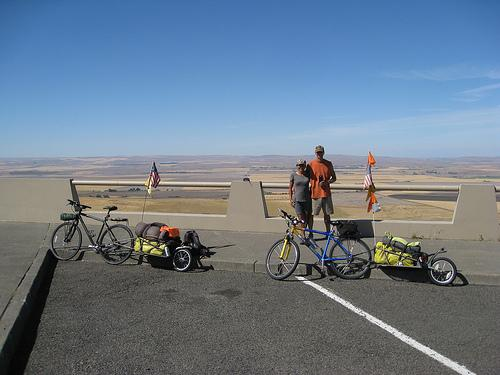What is the state of the sky in the image? The sky in the image is blue with white clouds. What are the two people in the image wearing? The male is wearing an orange shirt, and the female is wearing a gray shirt. Are there any flags in the image? If yes, describe the flags. Yes, there are flags in the image, including an American flag and a set of colored flags. Provide a brief description of the scene in the image. The image shows a row of bicycles with back seats parked in a gray parking lot, with owners nearby, under a blue sky with white clouds. Identify the primary object in the image and its color. The primary object in the image is a black bicycle with a back seat. What type of bikes are the black and blue bicycles? The black and blue bicycles are mountain bikes with back seats. What elements of the image reveal the season or weather conditions at the time the photo was taken? The blue sky with white clouds, owners of bicycles wearing shirts, and the clear atmosphere indicate that it might be a warm and sunny day during spring or summer. How many bikes are mentioned, and what are their colors? There are four bikes mentioned with colors; black, blue, and two instances with an unspecified color. 